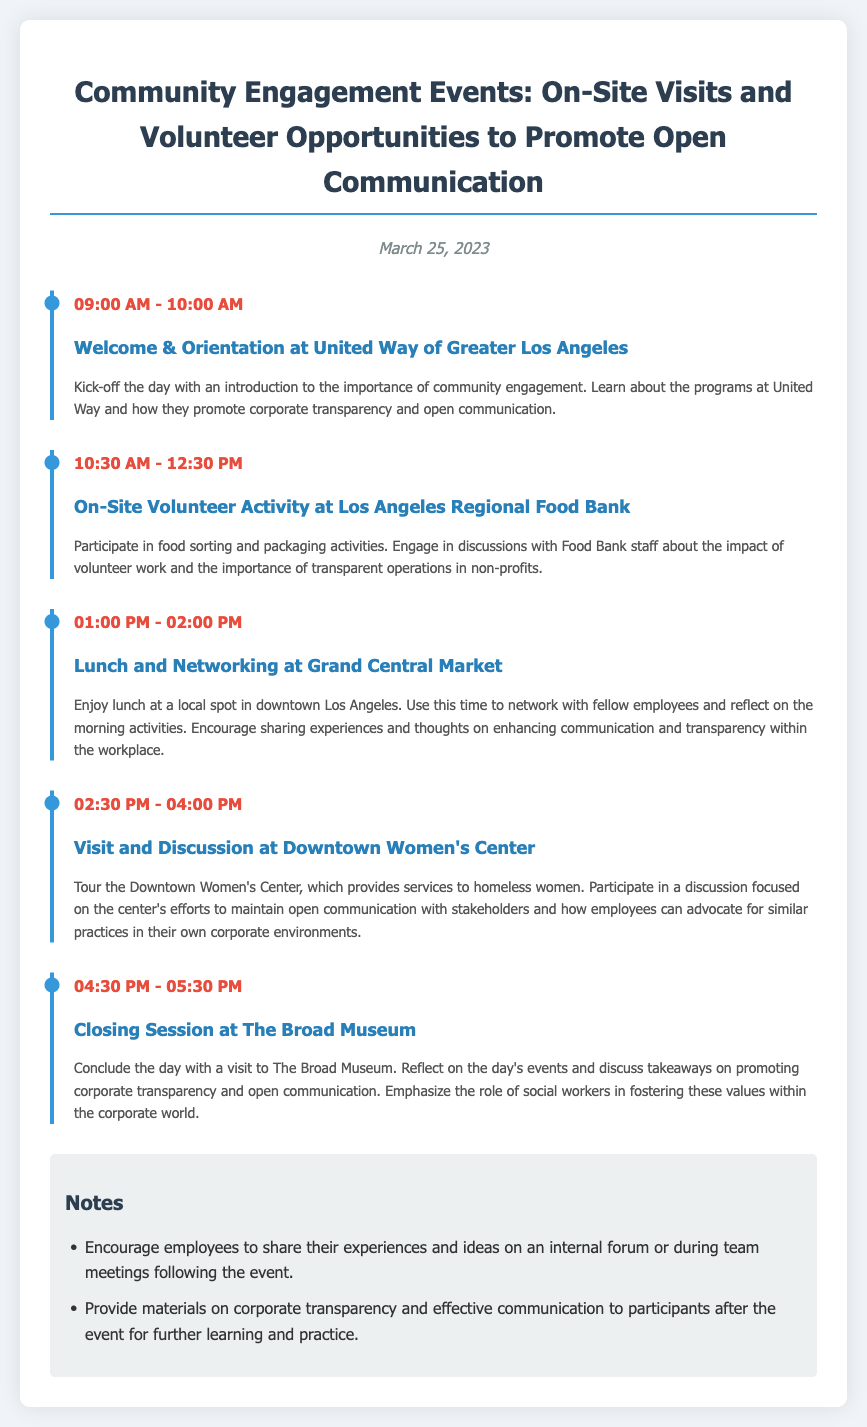What time does the Welcome & Orientation start? The Welcome & Orientation starts at 09:00 AM as indicated in the itinerary.
Answer: 09:00 AM What organization is hosting the On-Site Volunteer Activity? The On-Site Volunteer Activity is hosted at the Los Angeles Regional Food Bank, as mentioned in the event description.
Answer: Los Angeles Regional Food Bank How long is the Lunch and Networking session? The Lunch and Networking session lasts for one hour, as specified in the event's time frame from 01:00 PM to 02:00 PM.
Answer: 1 hour What is the primary focus of the visit to the Downtown Women's Center? The primary focus is on maintaining open communication with stakeholders, according to the description of the visit.
Answer: Open communication What is one takeaway emphasized during the Closing Session? One takeaway emphasized is the role of social workers in fostering corporate transparency and open communication, as detailed in the session description.
Answer: Social workers' role 